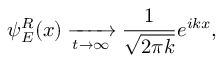<formula> <loc_0><loc_0><loc_500><loc_500>\psi _ { E } ^ { R } ( x ) \xrightarrow [ t \to \infty \frac { 1 } \sqrt { 2 \pi k } } e ^ { i k x } ,</formula> 